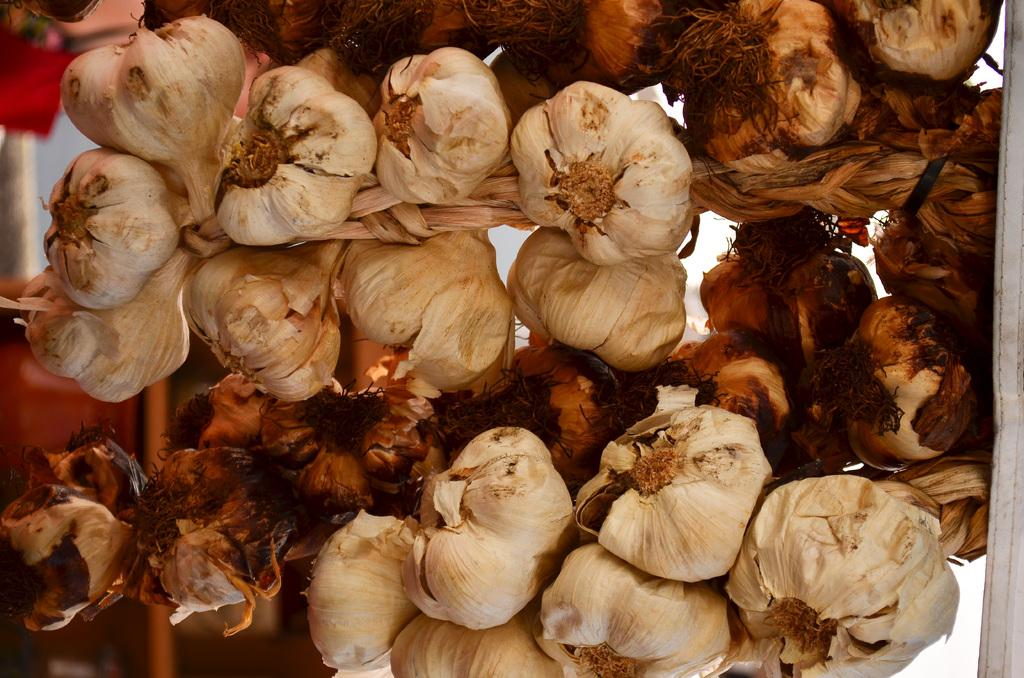What type of food item is present in the image? There are garlics in the image. What type of crown is the dog wearing in the image? There is no dog or crown present in the image; it only features garlics. What scientific experiment is being conducted with the garlics in the image? There is no scientific experiment depicted in the image; it simply shows garlics. 